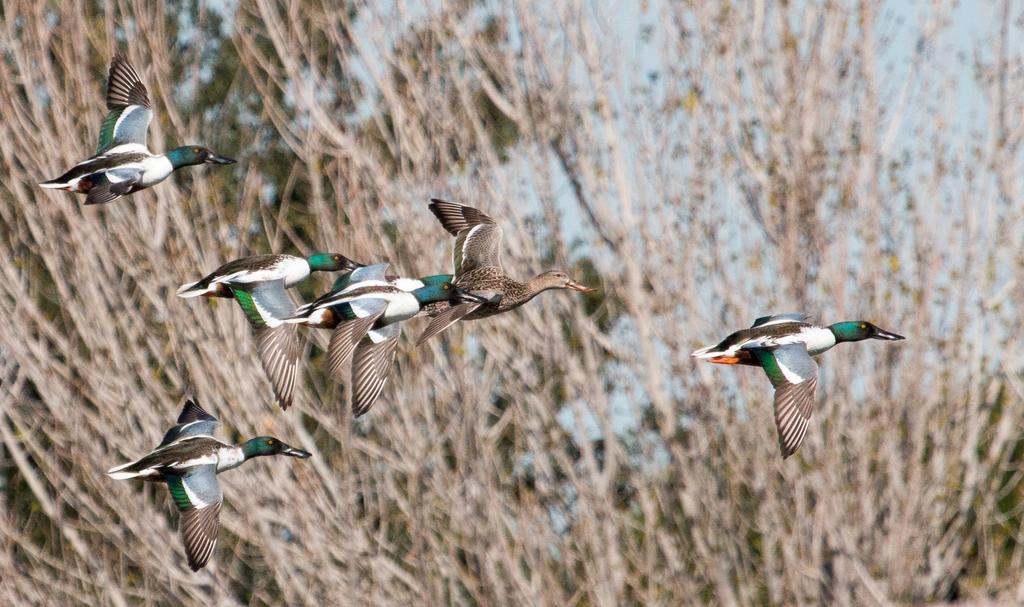Where was the image taken? The image was clicked outside. What is the main subject in the middle of the image? There are many birds in the middle of the image. What can be seen in the background of the image? There are plants visible in the background of the image. What type of mitten is being used by the birds in the image? There are no mittens present in the image; it features birds and plants. Is there a slope visible in the image? There is no slope visible in the image; it is focused on birds and plants. 